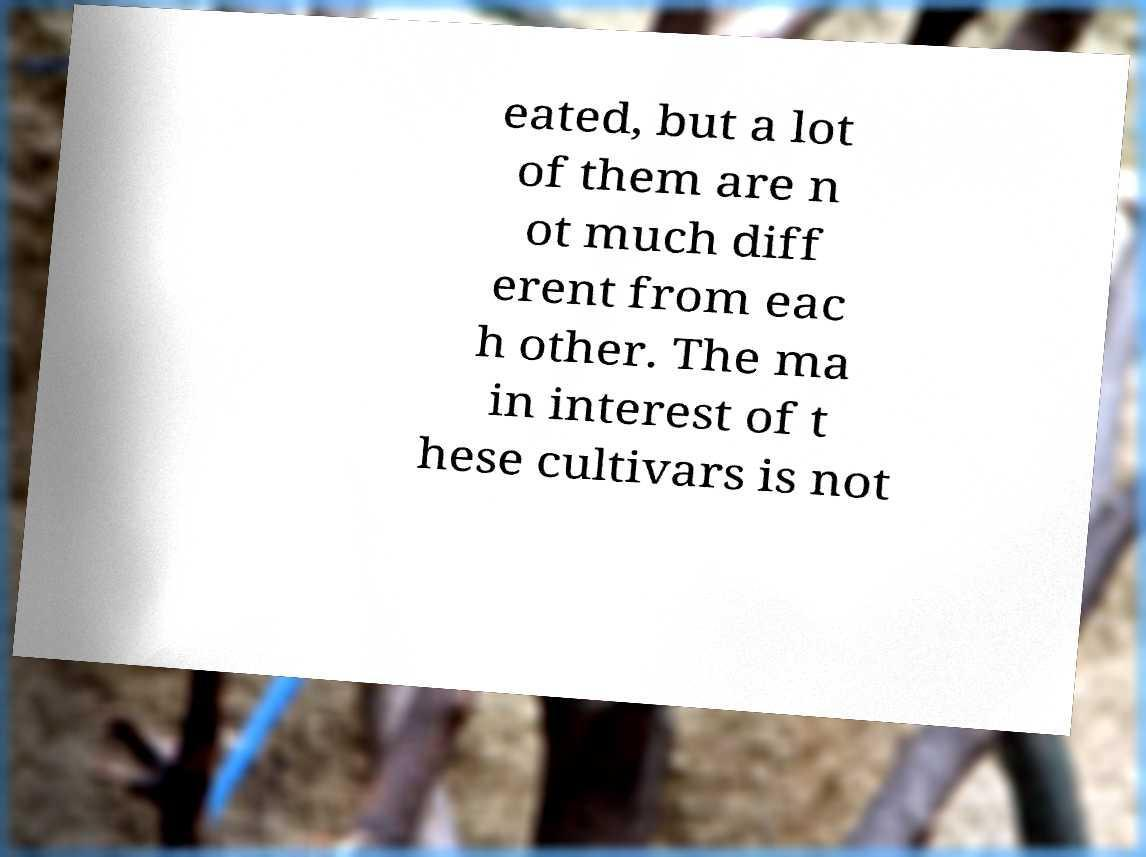Please identify and transcribe the text found in this image. eated, but a lot of them are n ot much diff erent from eac h other. The ma in interest of t hese cultivars is not 